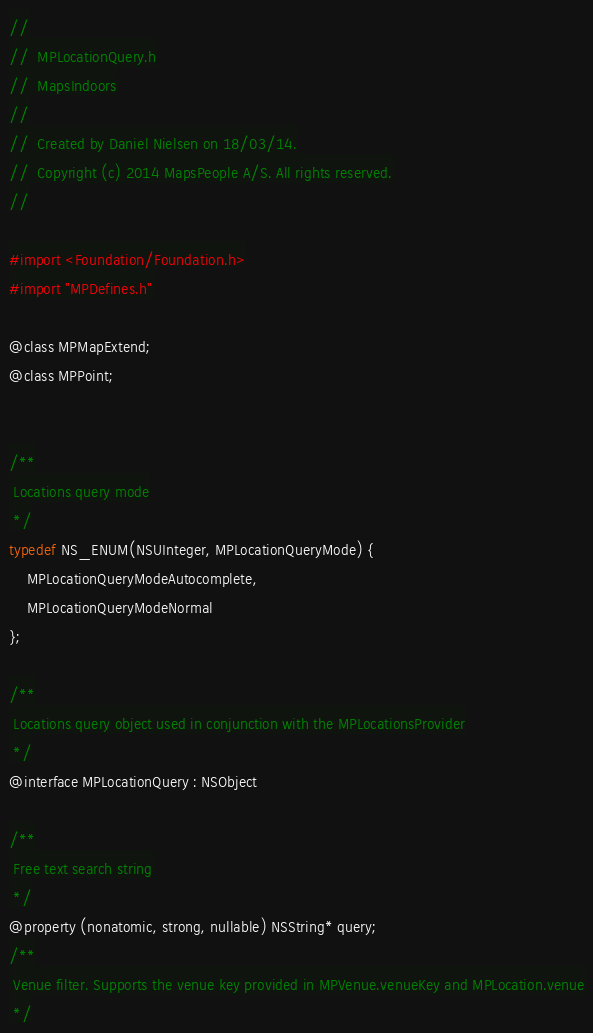<code> <loc_0><loc_0><loc_500><loc_500><_C_>//
//  MPLocationQuery.h
//  MapsIndoors
//
//  Created by Daniel Nielsen on 18/03/14.
//  Copyright (c) 2014 MapsPeople A/S. All rights reserved.
//

#import <Foundation/Foundation.h>
#import "MPDefines.h"

@class MPMapExtend;
@class MPPoint;


/**
 Locations query mode
 */
typedef NS_ENUM(NSUInteger, MPLocationQueryMode) {
    MPLocationQueryModeAutocomplete,
    MPLocationQueryModeNormal
};

/**
 Locations query object used in conjunction with the MPLocationsProvider
 */
@interface MPLocationQuery : NSObject

/**
 Free text search string
 */
@property (nonatomic, strong, nullable) NSString* query;
/**
 Venue filter. Supports the venue key provided in MPVenue.venueKey and MPLocation.venue
 */</code> 